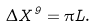Convert formula to latex. <formula><loc_0><loc_0><loc_500><loc_500>\Delta X ^ { 9 } = \pi L .</formula> 